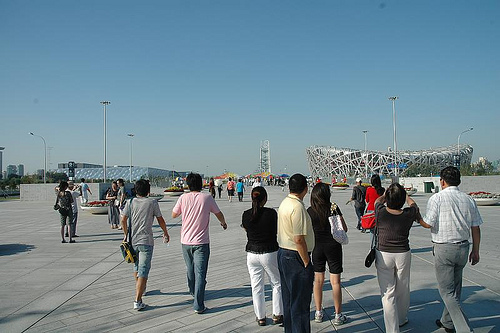<image>
Can you confirm if the woman is to the left of the woman? Yes. From this viewpoint, the woman is positioned to the left side relative to the woman. Is there a bag behind the man? No. The bag is not behind the man. From this viewpoint, the bag appears to be positioned elsewhere in the scene. 